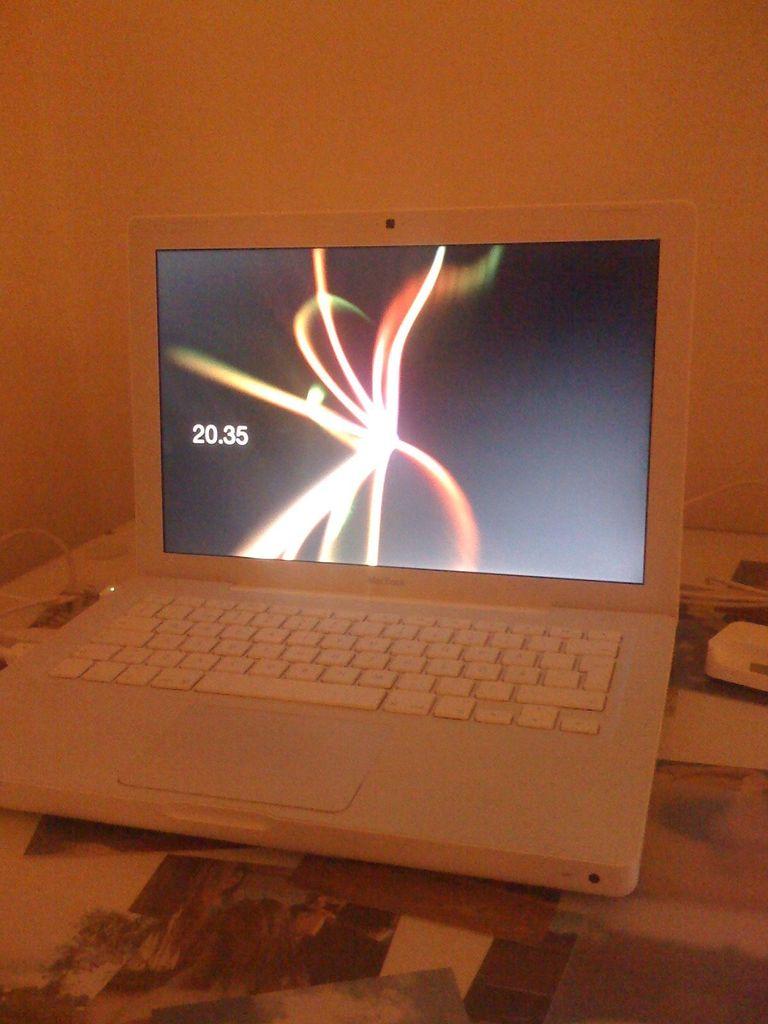What time is it on the screen?
Your answer should be very brief. 20:35. 